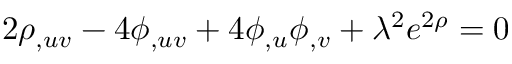Convert formula to latex. <formula><loc_0><loc_0><loc_500><loc_500>2 \rho _ { , u v } - 4 \phi _ { , u v } + 4 \phi _ { , u } \phi _ { , v } + \lambda ^ { 2 } e ^ { 2 \rho } = 0</formula> 